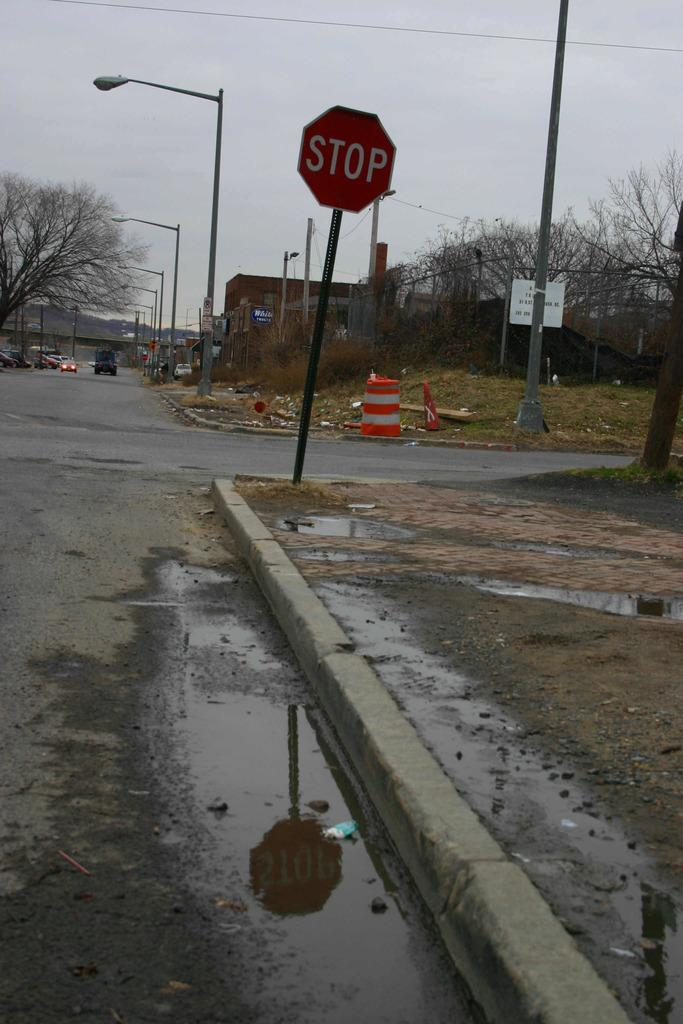<image>
Render a clear and concise summary of the photo. A stop sign on the side of a waterlogged road. 